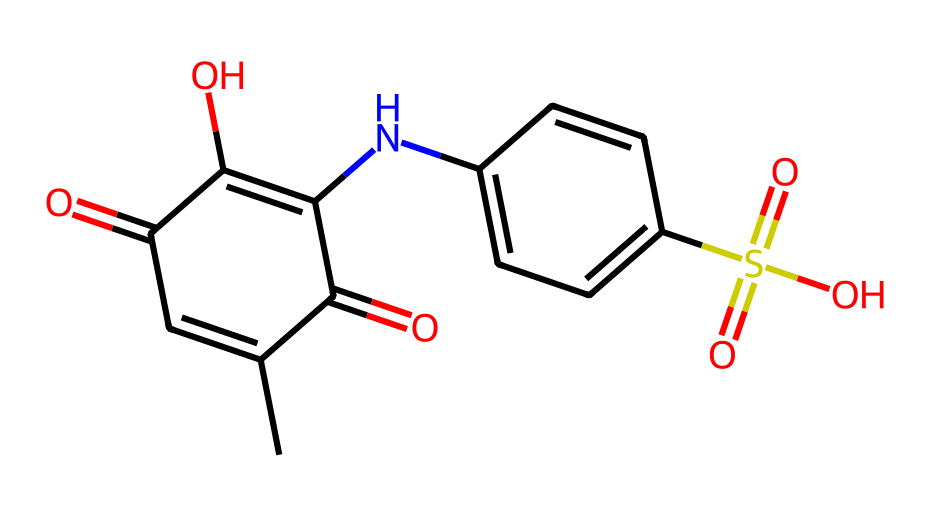How many carbon atoms are in this compound? By analyzing the SMILES representation, we can count the carbon atoms indicated by 'C' and 'CC'. In total, there are 12 carbon atoms present.
Answer: 12 What functional groups are present in this dye? The SMILES representation shows various groups: a carbonyl group (C=O), an amine group (N), and a sulfonic acid group (S(=O)(=O)O). These indicate that this molecule has multiple functional groups, namely carbonyl, amino, and sulfonic acid groups.
Answer: carbonyl, amino, sulfonic acid Is this compound likely soluble in water? The presence of the sulfonic acid group (S(=O)(=O)O) suggests that this compound is likely to be ionic or highly polar, which usually enhances solubility in water.
Answer: likely What is the total number of nitrogen atoms in the chemical structure? By examining the SMILES, we identify that there is one nitrogen atom (N) in the structure, confirming the count of nitrogen.
Answer: 1 Which part of the molecule is responsible for the color of this dye? The conjugated system of double bonds and the presence of aromatic rings are responsible for the color properties of dyes. In this case, the parts containing the aromatic rings and the extended pi system likely contribute to the color.
Answer: aromatic rings What type of bond connects the nitrogen atom to the carbon atom in this molecule? In the structure, the bond between the nitrogen (N) and the adjacent carbon atom shows a single bond typically involved in amine characteristics. Thus, it's a single covalent bond.
Answer: single covalent bond 